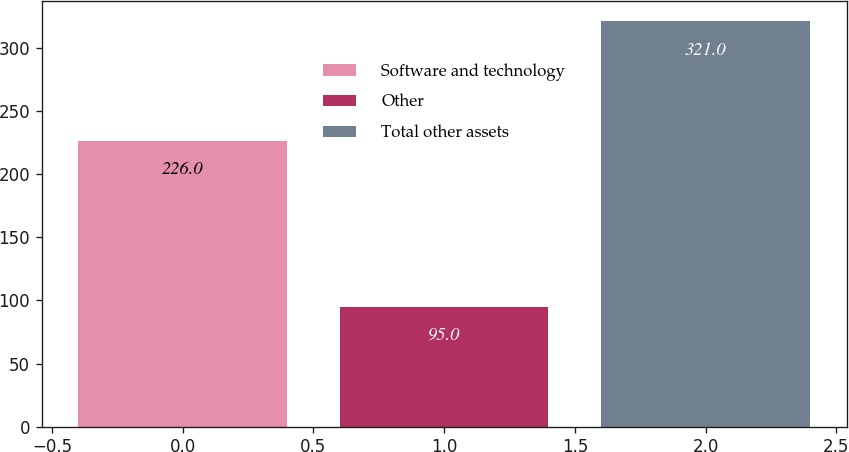Convert chart to OTSL. <chart><loc_0><loc_0><loc_500><loc_500><bar_chart><fcel>Software and technology<fcel>Other<fcel>Total other assets<nl><fcel>226<fcel>95<fcel>321<nl></chart> 